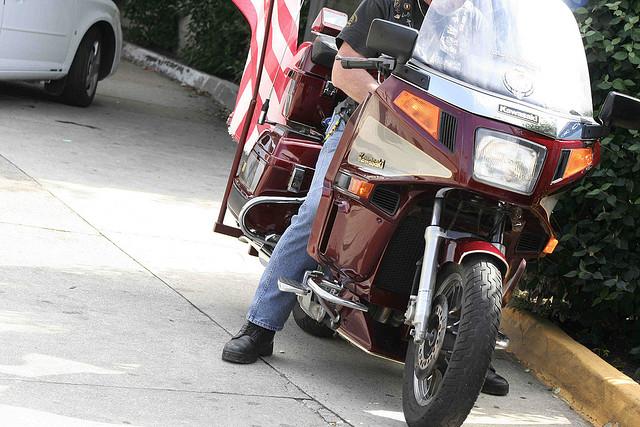Is the motorcycle in motion?
Write a very short answer. No. What type of pants is the rider wearing?
Keep it brief. Jeans. Where is the motorcycle's maker based?
Keep it brief. Japan. 